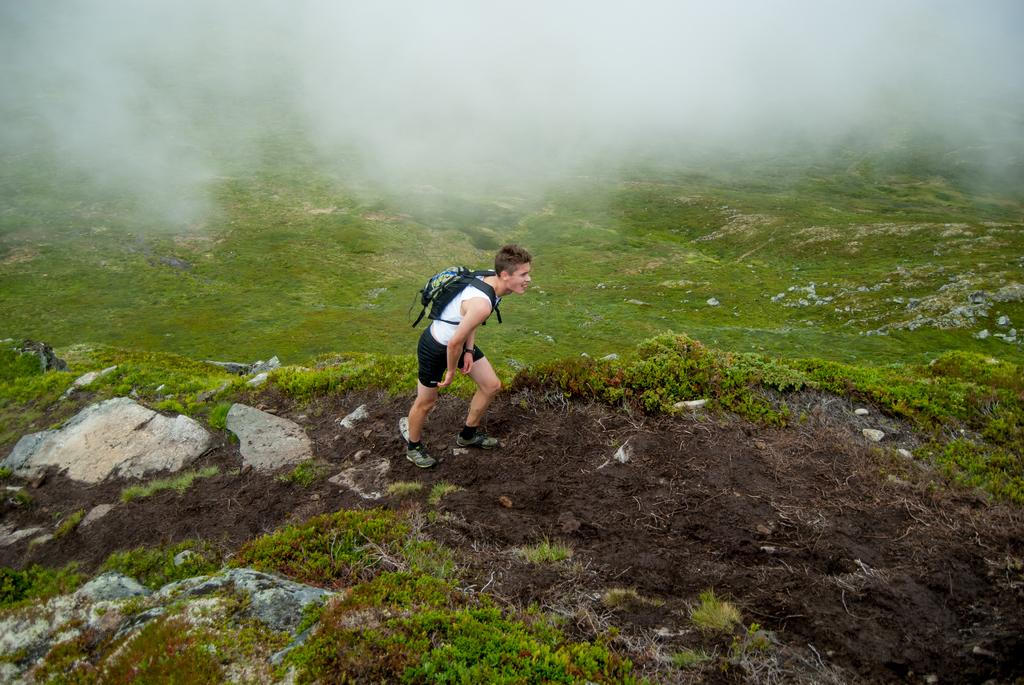Who is the person in the image? There is a man in the image. What is the man doing in the image? The man is climbing a mountain. What is the terrain like around the man? The land around the man is covered with grass. What is the man carrying on his back? The man is wearing a backpack. What is the weather like in the image? The climate in the image is covered with snow and fog. What type of poisonous plant can be seen near the man in the image? There is no poisonous plant visible near the man in the image. What note is the man holding in his hand while climbing the mountain? The man is not holding any note in his hand while climbing the mountain; he is wearing a backpack. 